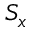<formula> <loc_0><loc_0><loc_500><loc_500>S _ { x }</formula> 